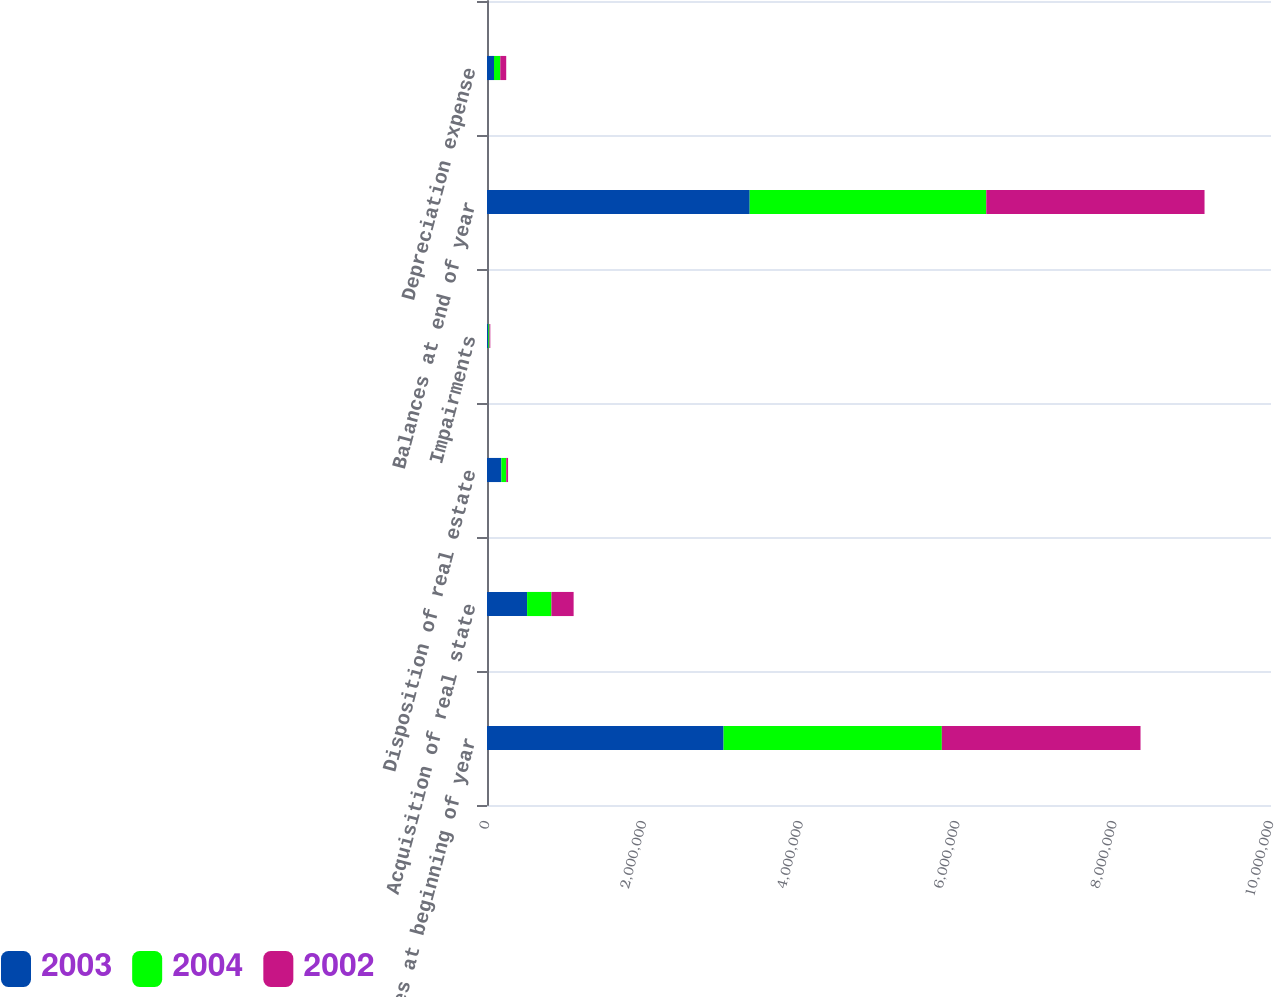<chart> <loc_0><loc_0><loc_500><loc_500><stacked_bar_chart><ecel><fcel>Balances at beginning of year<fcel>Acquisition of real state<fcel>Disposition of real estate<fcel>Impairments<fcel>Balances at end of year<fcel>Depreciation expense<nl><fcel>2003<fcel>3.01746e+06<fcel>511448<fcel>183012<fcel>17067<fcel>3.35094e+06<fcel>89357<nl><fcel>2004<fcel>2.7838e+06<fcel>310151<fcel>62497<fcel>13992<fcel>3.01746e+06<fcel>80123<nl><fcel>2002<fcel>2.53453e+06<fcel>283345<fcel>23066<fcel>11007<fcel>2.7838e+06<fcel>75636<nl></chart> 